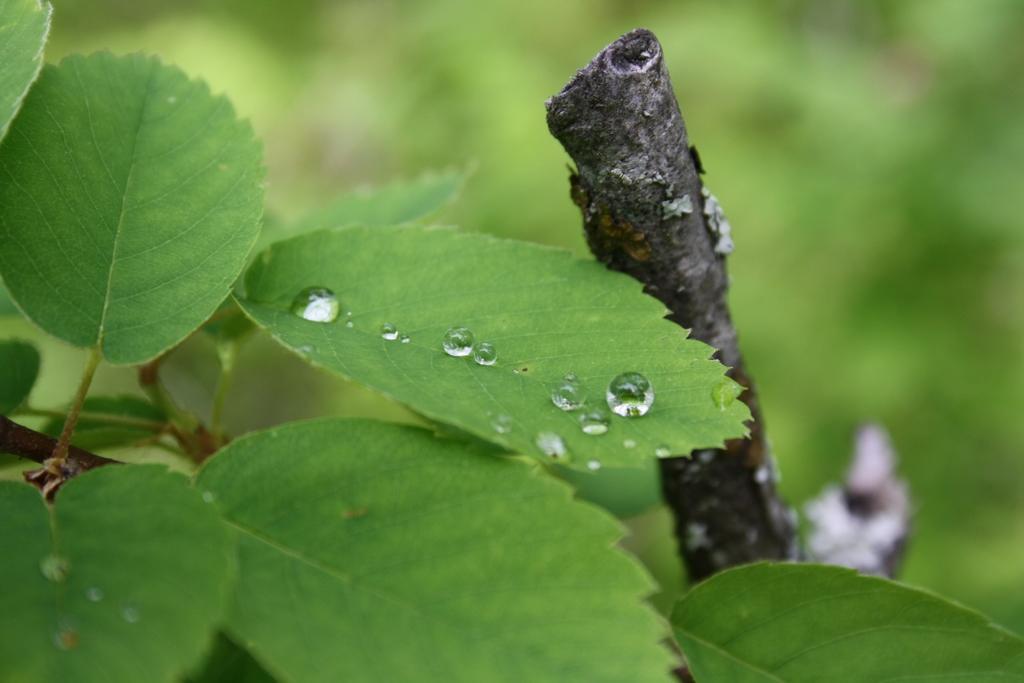Describe this image in one or two sentences. In the center of the image there are leaves. There is a stem. The background of the image is blur. 